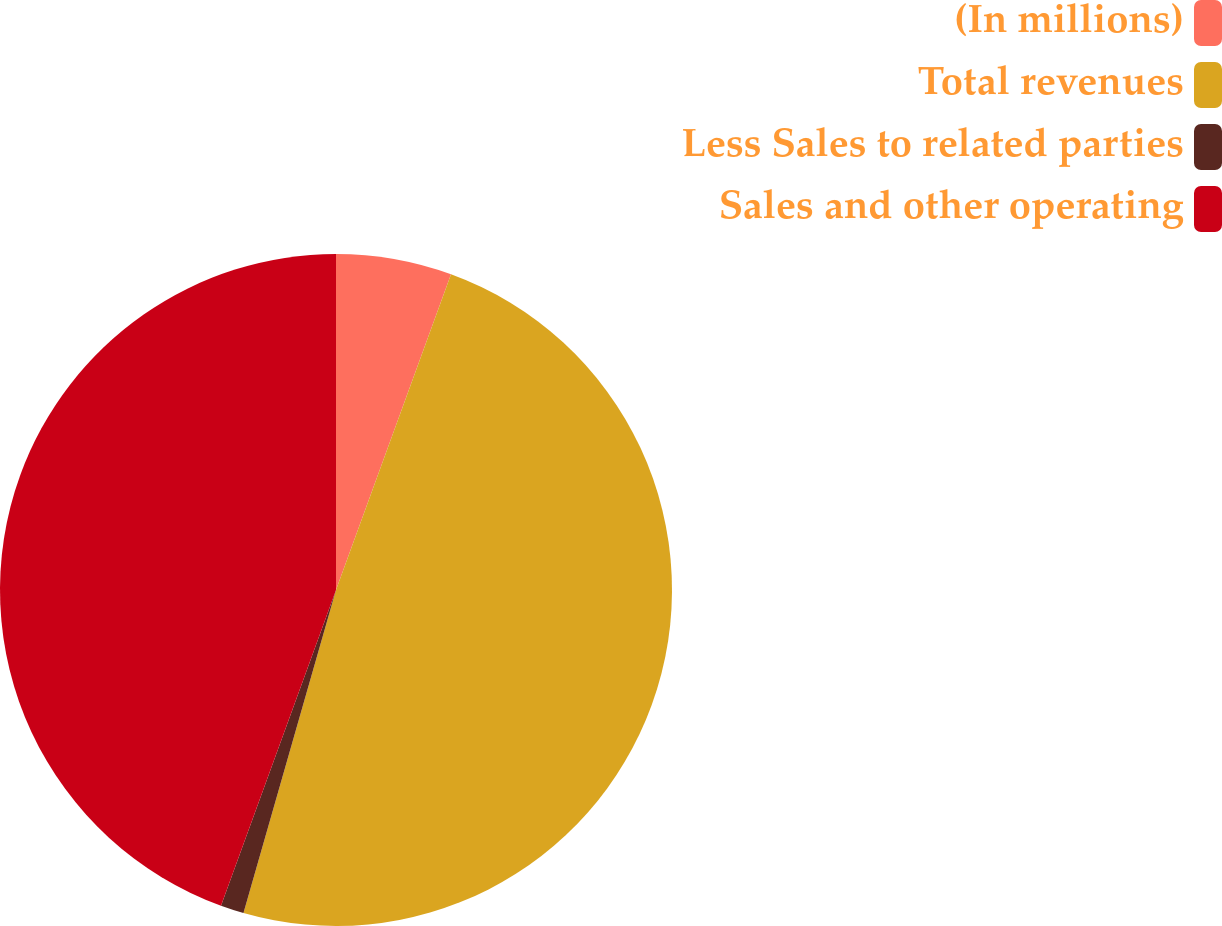Convert chart to OTSL. <chart><loc_0><loc_0><loc_500><loc_500><pie_chart><fcel>(In millions)<fcel>Total revenues<fcel>Less Sales to related parties<fcel>Sales and other operating<nl><fcel>5.56%<fcel>48.88%<fcel>1.12%<fcel>44.44%<nl></chart> 